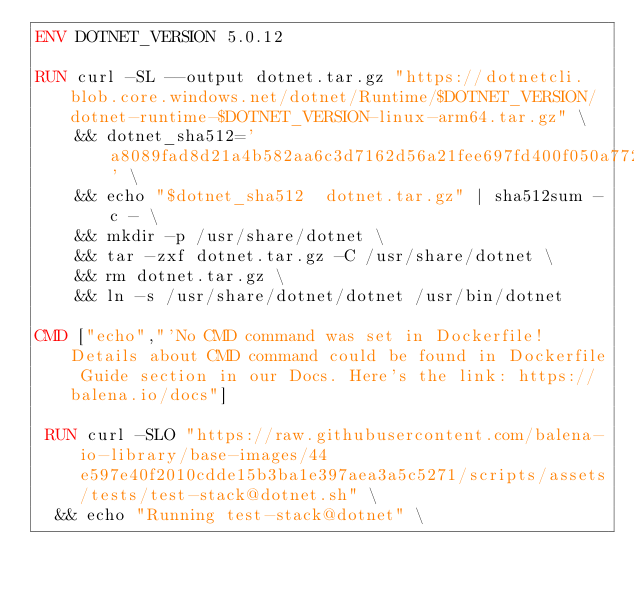<code> <loc_0><loc_0><loc_500><loc_500><_Dockerfile_>ENV DOTNET_VERSION 5.0.12

RUN curl -SL --output dotnet.tar.gz "https://dotnetcli.blob.core.windows.net/dotnet/Runtime/$DOTNET_VERSION/dotnet-runtime-$DOTNET_VERSION-linux-arm64.tar.gz" \
    && dotnet_sha512='a8089fad8d21a4b582aa6c3d7162d56a21fee697fd400f050a772f67c2ace5e4196d1c4261d3e861d6dc2e5439666f112c406104d6271e5ab60cda80ef2ffc64' \
    && echo "$dotnet_sha512  dotnet.tar.gz" | sha512sum -c - \
    && mkdir -p /usr/share/dotnet \
    && tar -zxf dotnet.tar.gz -C /usr/share/dotnet \
    && rm dotnet.tar.gz \
    && ln -s /usr/share/dotnet/dotnet /usr/bin/dotnet

CMD ["echo","'No CMD command was set in Dockerfile! Details about CMD command could be found in Dockerfile Guide section in our Docs. Here's the link: https://balena.io/docs"]

 RUN curl -SLO "https://raw.githubusercontent.com/balena-io-library/base-images/44e597e40f2010cdde15b3ba1e397aea3a5c5271/scripts/assets/tests/test-stack@dotnet.sh" \
  && echo "Running test-stack@dotnet" \</code> 